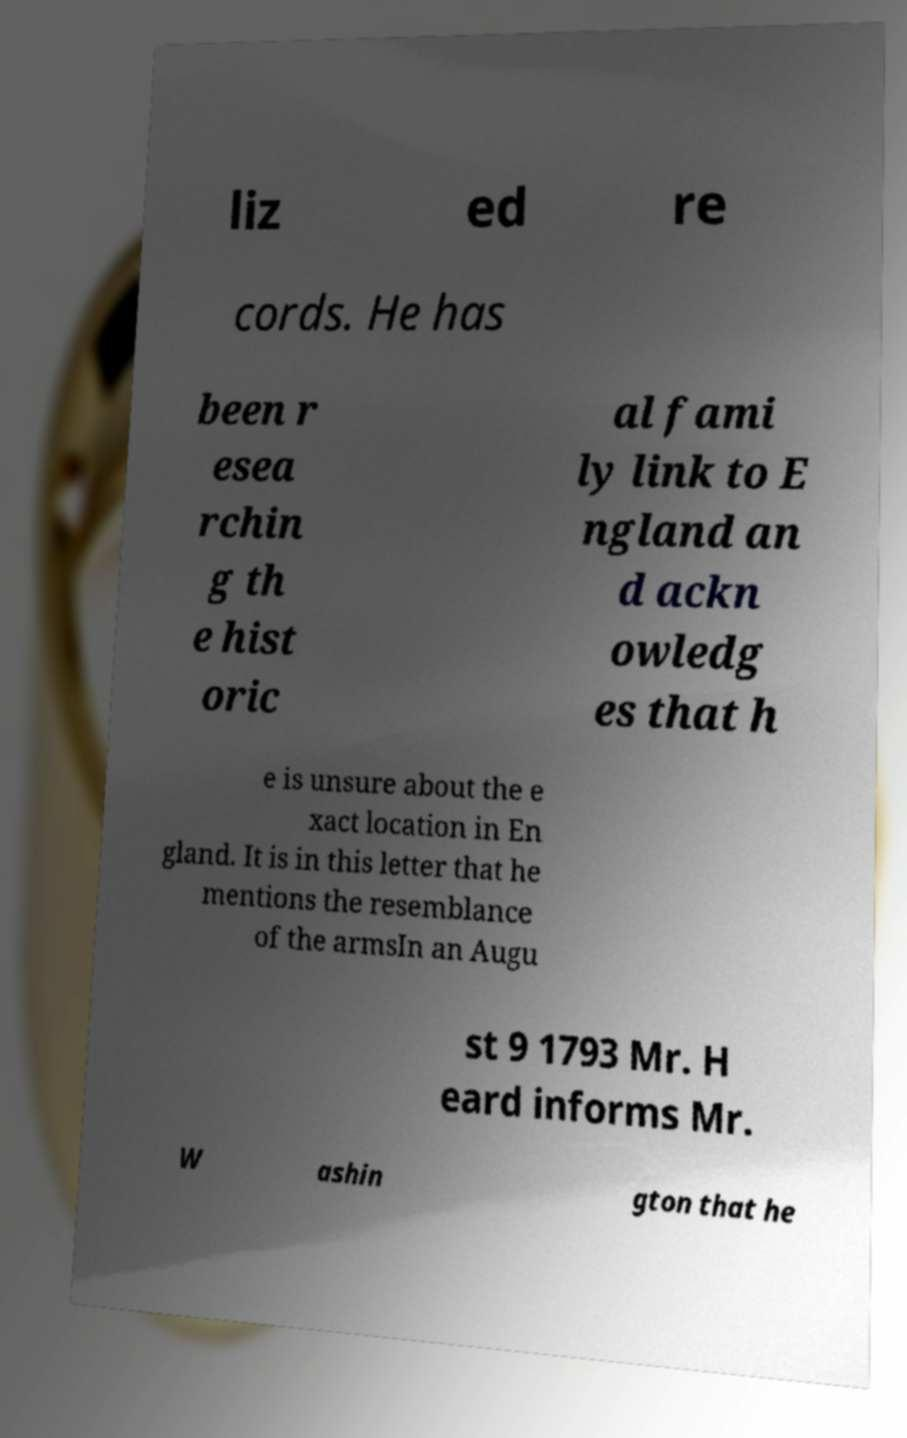Could you extract and type out the text from this image? liz ed re cords. He has been r esea rchin g th e hist oric al fami ly link to E ngland an d ackn owledg es that h e is unsure about the e xact location in En gland. It is in this letter that he mentions the resemblance of the armsIn an Augu st 9 1793 Mr. H eard informs Mr. W ashin gton that he 